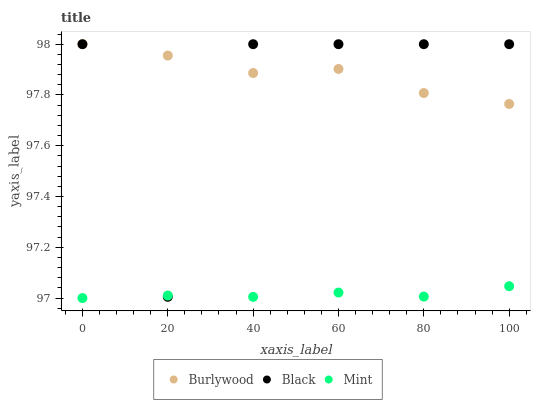Does Mint have the minimum area under the curve?
Answer yes or no. Yes. Does Burlywood have the maximum area under the curve?
Answer yes or no. Yes. Does Black have the minimum area under the curve?
Answer yes or no. No. Does Black have the maximum area under the curve?
Answer yes or no. No. Is Mint the smoothest?
Answer yes or no. Yes. Is Black the roughest?
Answer yes or no. Yes. Is Black the smoothest?
Answer yes or no. No. Is Mint the roughest?
Answer yes or no. No. Does Mint have the lowest value?
Answer yes or no. Yes. Does Black have the lowest value?
Answer yes or no. No. Does Black have the highest value?
Answer yes or no. Yes. Does Mint have the highest value?
Answer yes or no. No. Is Mint less than Burlywood?
Answer yes or no. Yes. Is Burlywood greater than Mint?
Answer yes or no. Yes. Does Burlywood intersect Black?
Answer yes or no. Yes. Is Burlywood less than Black?
Answer yes or no. No. Is Burlywood greater than Black?
Answer yes or no. No. Does Mint intersect Burlywood?
Answer yes or no. No. 